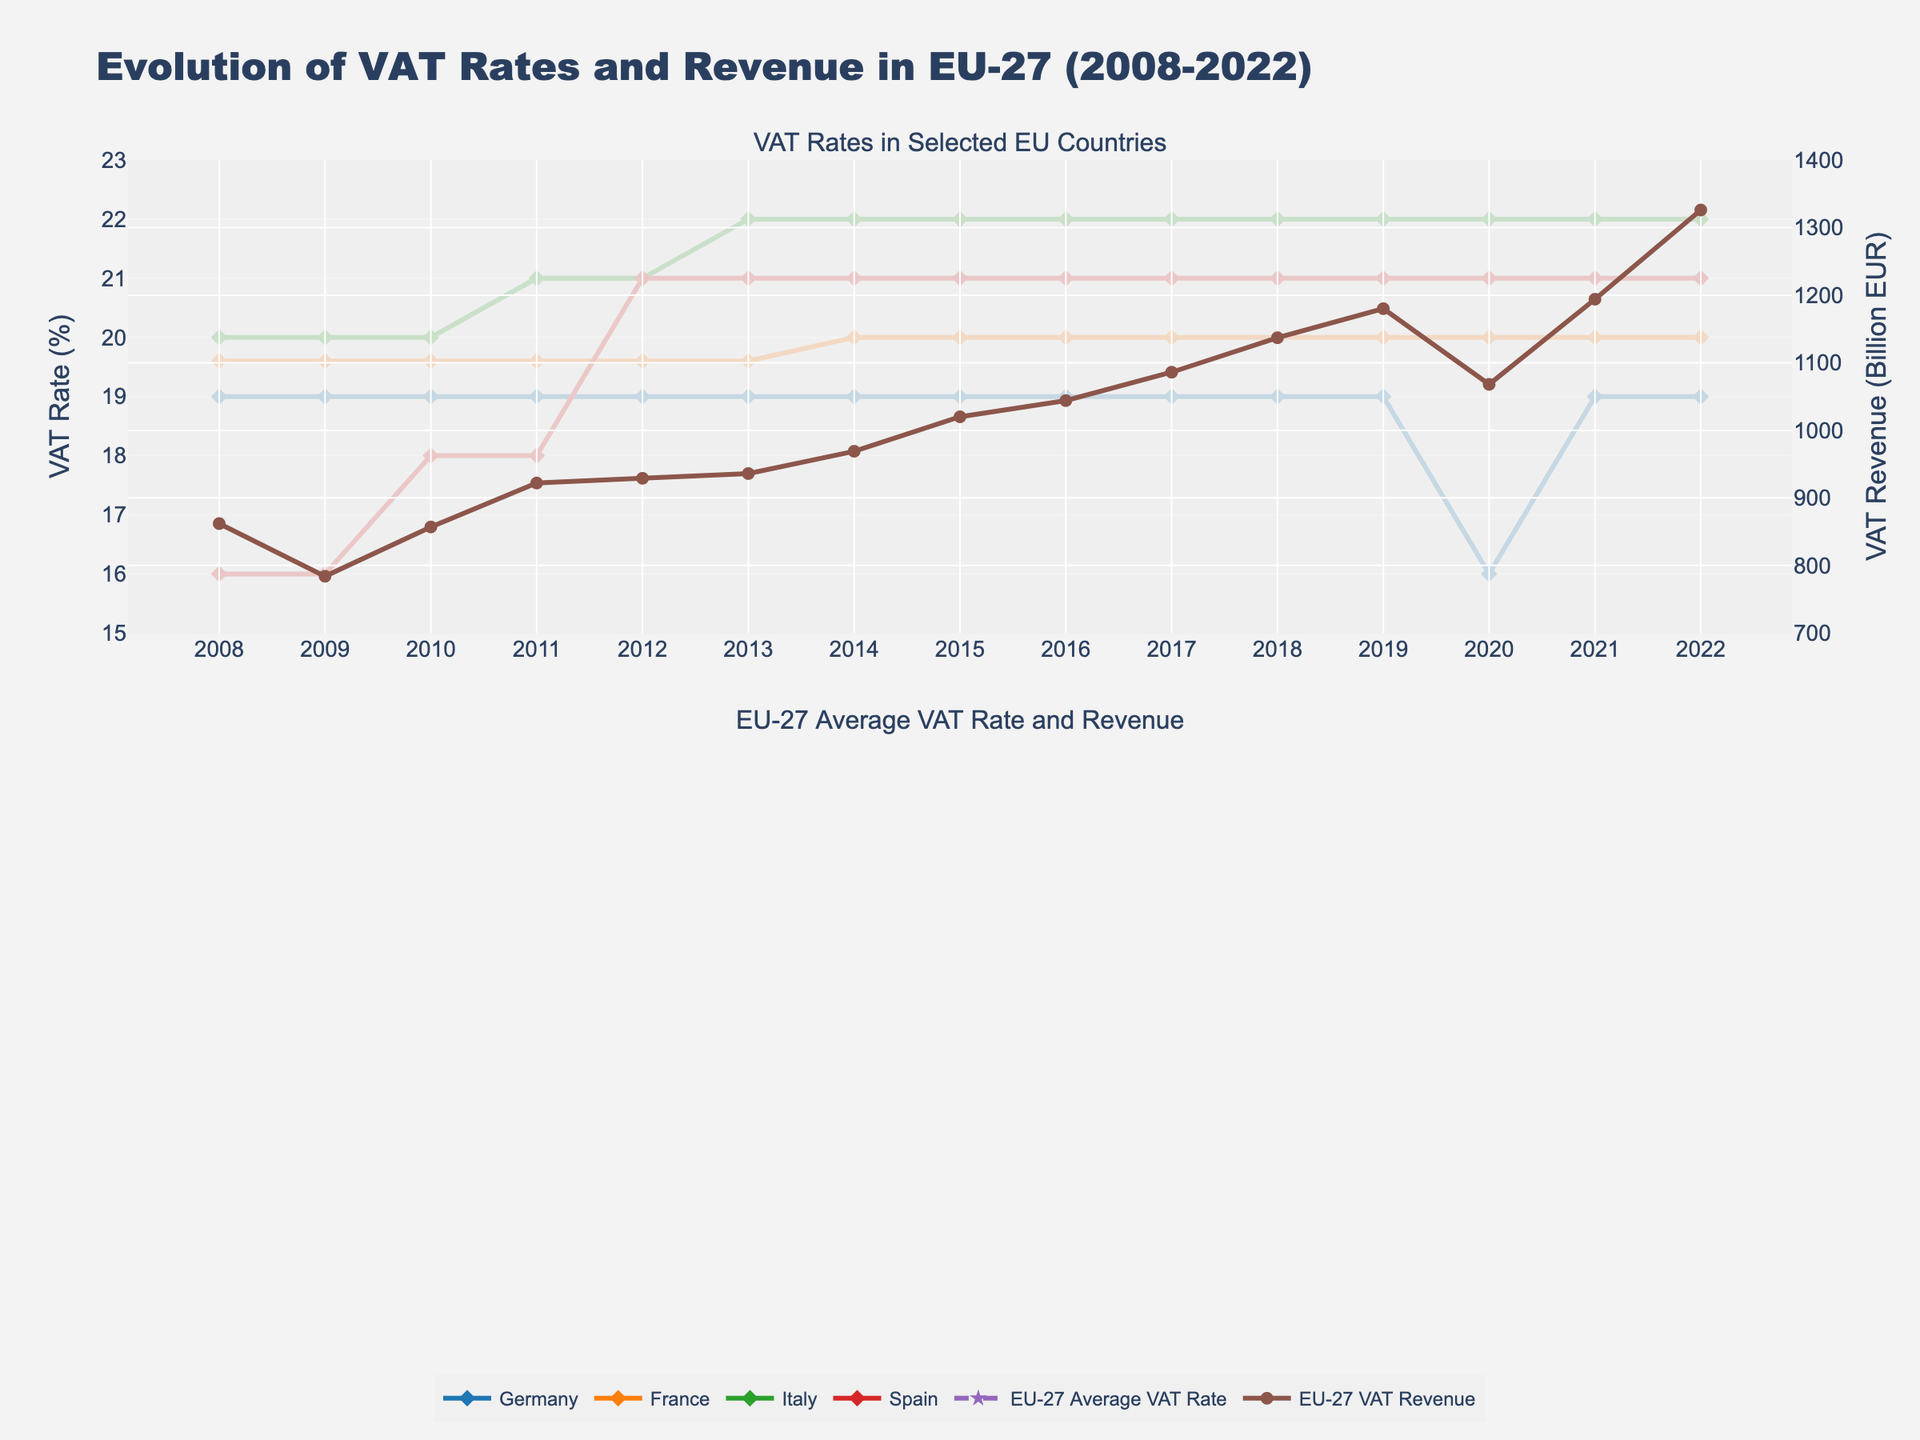What is the trend of the EU-27 average VAT rate from 2008 to 2022? The EU-27 average VAT rate increased from 19.5% in 2008 to 21.6% in 2015, then stabilized around 21.4% from 2019 to 2022. This can be seen by observing the overall upward slope from 2008 to 2015, and the relatively flat line afterwards.
Answer: The average VAT rate increased initially and then stabilized Which country had the most significant change in VAT rate during the observed period? Germany had a distinct change in its VAT rate from 19% to 16% in 2020, but then it reverted back to 19% in 2021. This is noticeable as a sharp drop and a subsequent rise in the line representing Germany in the first subplot.
Answer: Germany How did the EU-27 VAT revenue change from the 2008 financial crisis to 2022? The EU-27 VAT revenue showed a general increasing trend from 2008 to 2019, with a significant dip in 2020 likely due to the pandemic, and then continued an upward trajectory till 2022. By comparing the general heights of the line in the second subplot, we can see this pattern.
Answer: It increased with a dip in 2020 and continued rising afterwards In which year did Spain increase its VAT rate compared to the previous year for the first time? Spain first increased its VAT rate in 2010 from 16% to 18%. This is observed by the vertical jump in the line representing Spain between 2009 and 2010 in the first subplot.
Answer: 2010 What was the difference in the VAT revenue between 2021 and 2022 for the EU-27? The VAT revenue was 1194 billion EUR in 2021 and 1326 billion EUR in 2022. The difference is 1326 - 1194 = 132 billion EUR. This is found by comparing the vertical positions of the line representing VAT revenue for these two years.
Answer: 132 billion EUR Which country's VAT rate remained the same throughout the entire period? France's VAT rate stayed constant at 19.6% from 2008 to 2022. This can be inferred by observing the horizontal, unchanging line for France in the first subplot.
Answer: France Was there any correlation between the changes in the average VAT rate and VAT revenue in the EU-27? Generally, as the average VAT rate increased from 2008 to 2019, the VAT revenue also increased. Despite a constant rate from 2019 to 2022, the revenue continued to rise except in 2020. Observing the synchronized upward slopes in the second subplot indicates a strong initial correlation.
Answer: Generally positive correlation Between 2012 and 2013, which country had a VAT rate increase, and by how much was it increased? Italy increased its VAT rate from 21% in 2012 to 22% in 2013. This is visible by seeing the line for Italy rise between these years in the first subplot.
Answer: Italy, increased by 1% How did the VAT rate for Germany change in 2020, and what was the impact on VAT revenue in the EU-27? Germany reduced its VAT rate from 19% to 16% in 2020, which was the lowest rate in the considered period. The EU-27 VAT revenue also saw a significant drop from 1180 billion EUR in 2019 to 1068 billion EUR in 2020. This drop in revenue is observed in alignment with the drop in Germany's VAT rate.
Answer: Germany reduced by 3%, and EU-27 VAT revenue decreased Among the selected countries (Germany, France, Italy, Spain), which had the highest VAT rate in 2022? Italy had the highest VAT rate of 22% in 2022 (compared to 19% for Germany, 20% for France, and 21% for Spain) as discerned from the respective positions of the lines in the first subplot for the year 2022.
Answer: Italy 